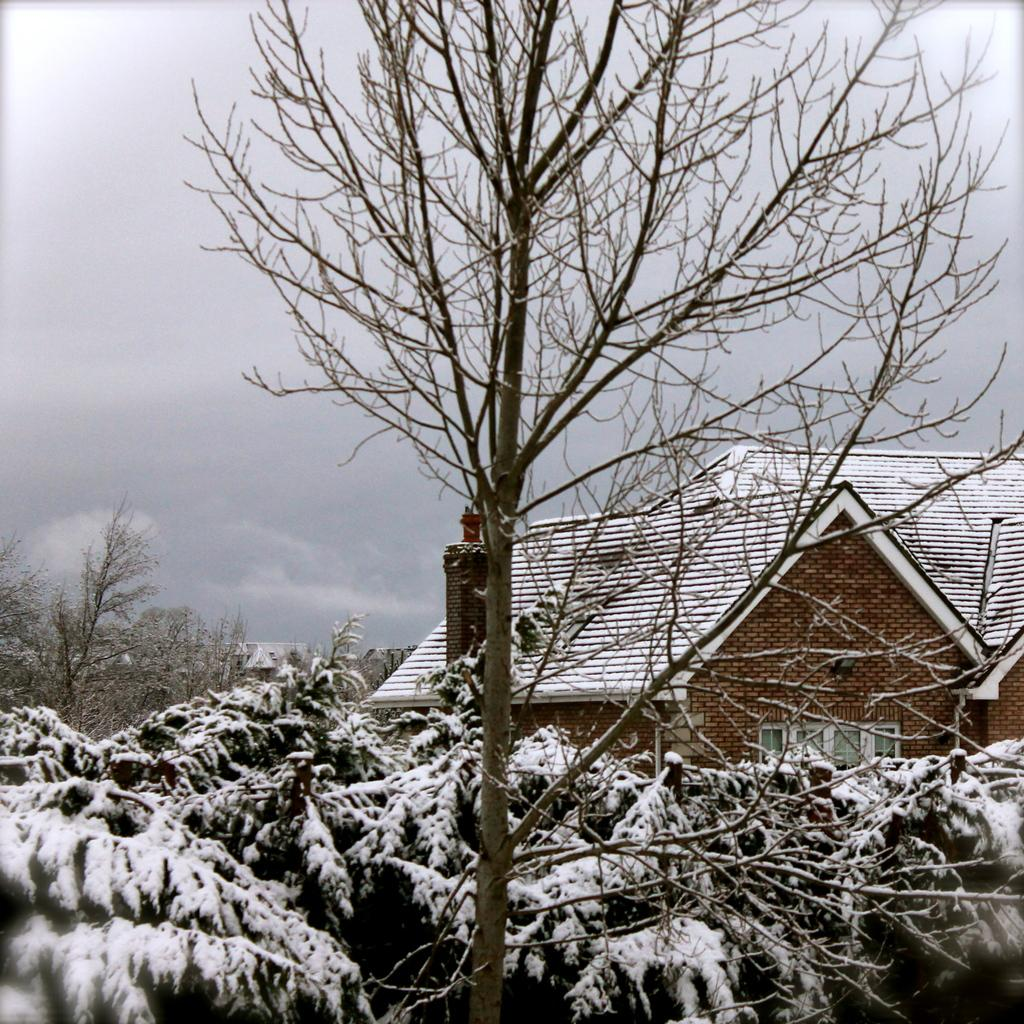What type of structure is present in the image? There is a house in the image. What other natural elements can be seen in the image? There are plants and trees visible in the image. How is the appearance of the plants and trees affected in the image? The plants and trees are covered with snow. What type of digestion problem is the house experiencing in the image? The house is not a living organism and therefore cannot experience digestion problems. Is there any indication that someone in the image is experiencing a cough? There is no information provided about anyone experiencing a cough in the image. 